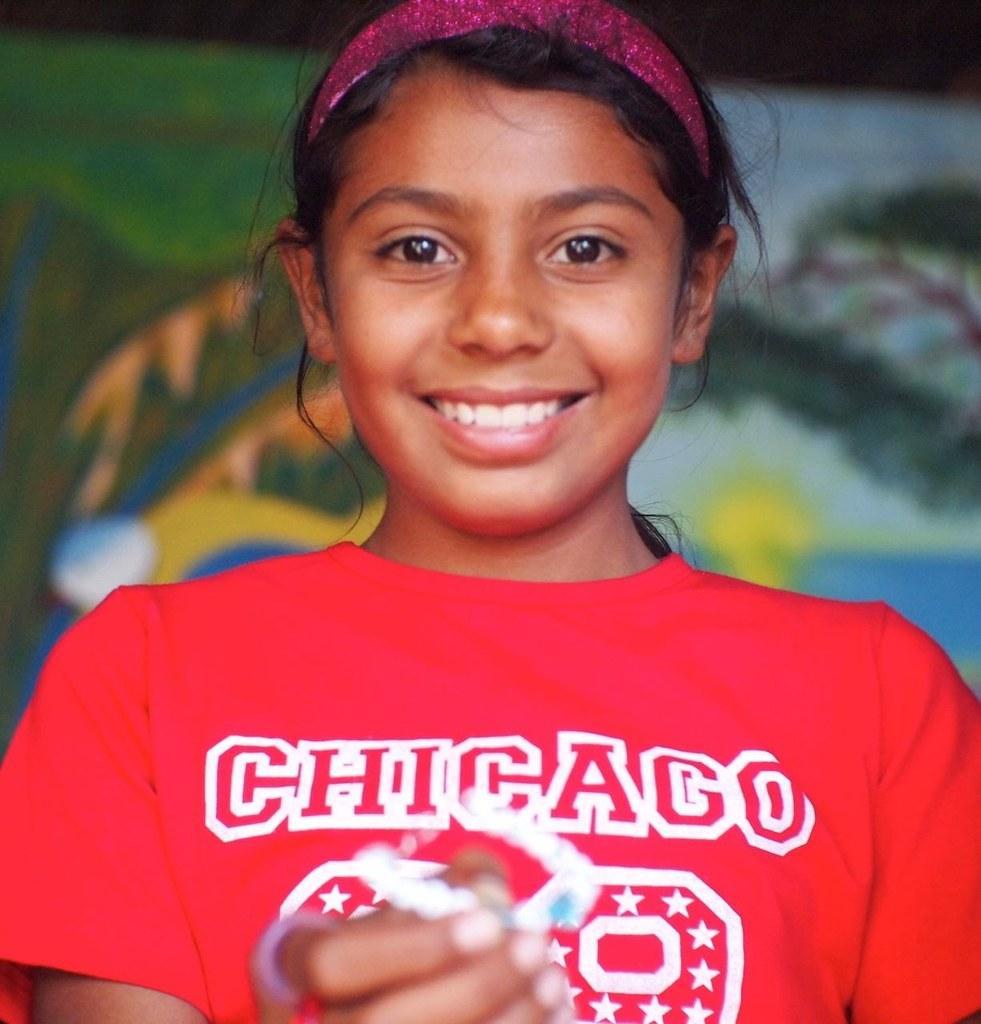Could you give a brief overview of what you see in this image? In this image we can see a girl wearing red t shirt and holding an object and smiling and the background is blurred with a painting. 